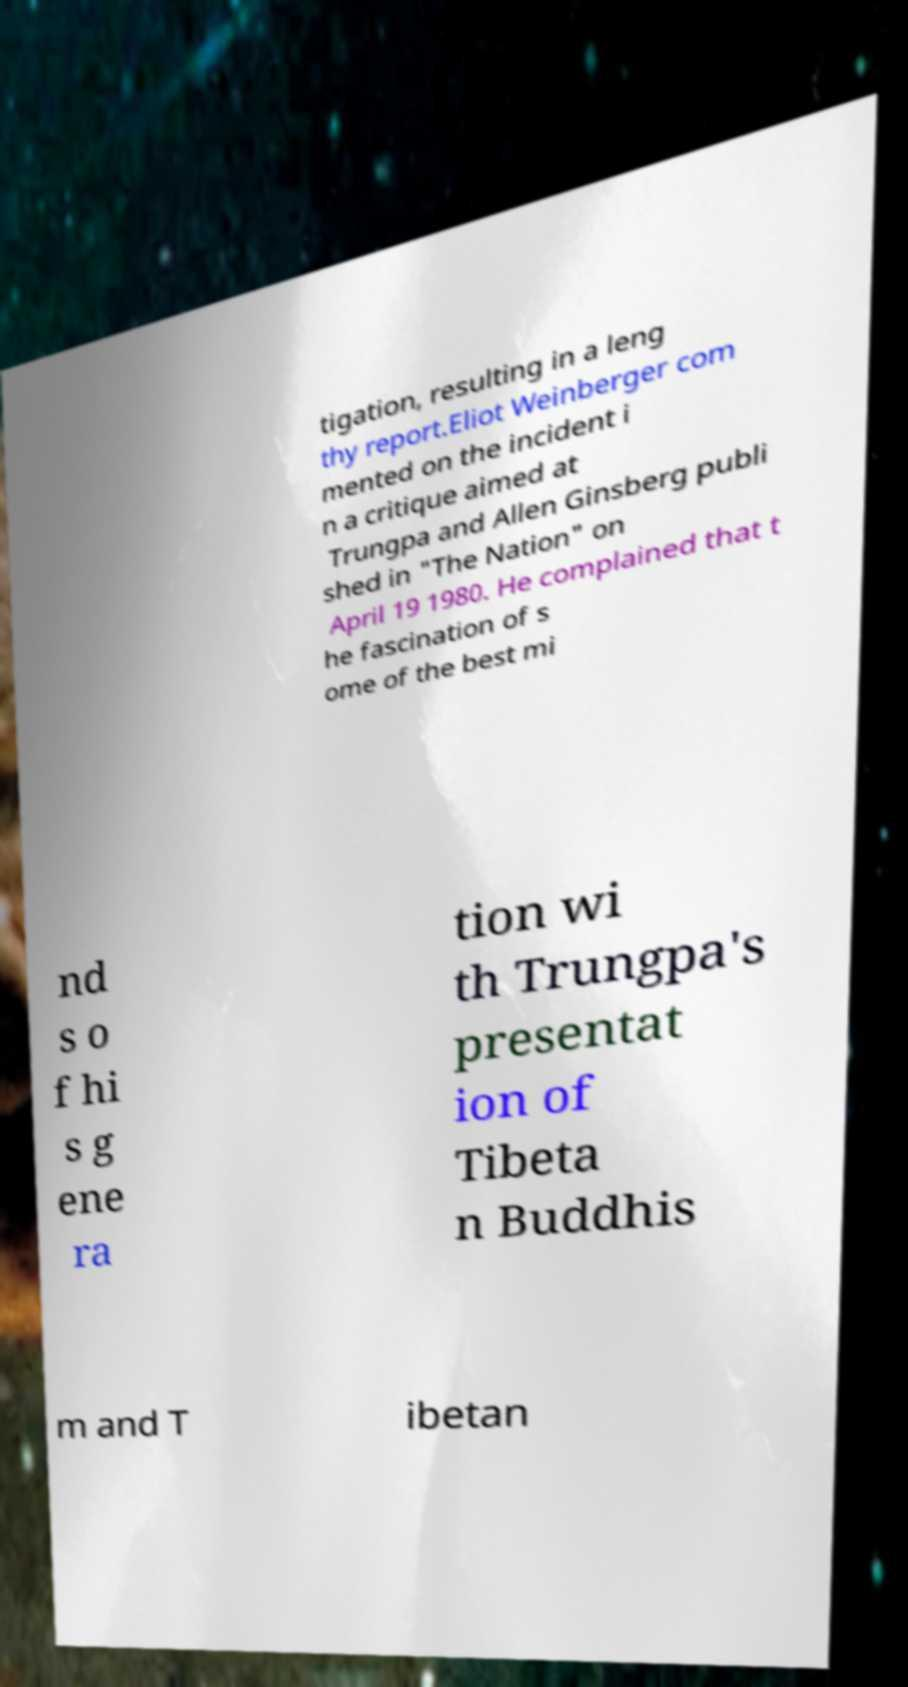Please identify and transcribe the text found in this image. tigation, resulting in a leng thy report.Eliot Weinberger com mented on the incident i n a critique aimed at Trungpa and Allen Ginsberg publi shed in "The Nation" on April 19 1980. He complained that t he fascination of s ome of the best mi nd s o f hi s g ene ra tion wi th Trungpa's presentat ion of Tibeta n Buddhis m and T ibetan 